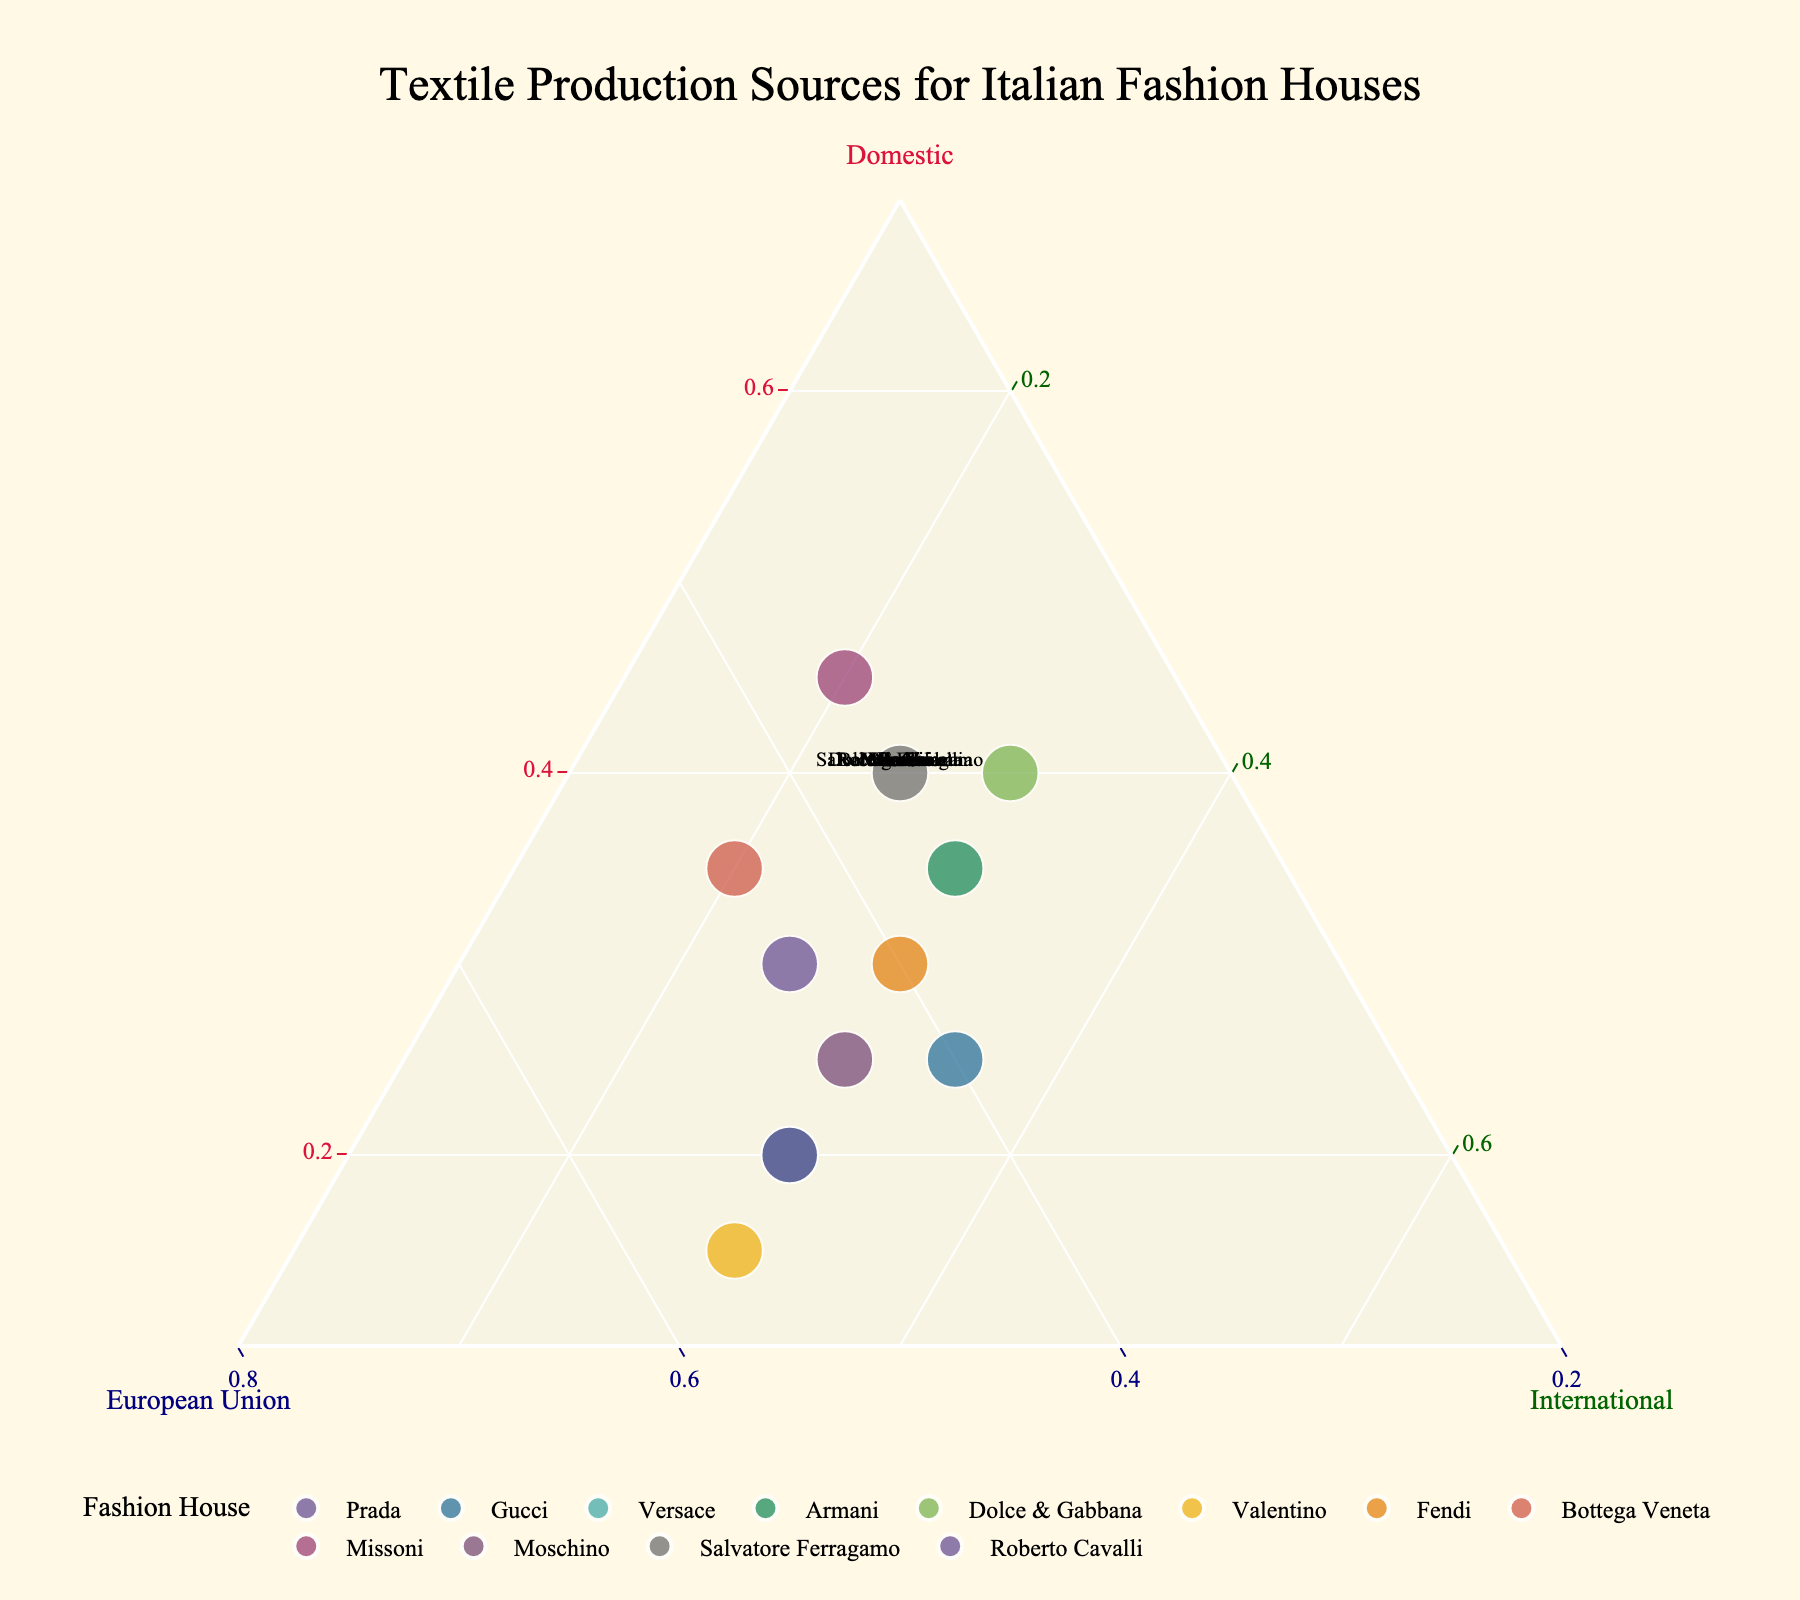what is the title of the plot? The title of the plot is located at the top center of the figure. Based on the code provided, the title is "Textile Production Sources for Italian Fashion Houses".
Answer: Textiles Production Sources for Italian Fashion Houses Which fashion house has the highest proportion of domestic textile production? The points representing each fashion house can be located within the ternary plot. By observing the axis labeled "Domestic" and finding the point closest to the vertex of that axis, Missoni has the highest proportion of domestic textile production, being closer to the Domestic vertex.
Answer: Missoni What is the balance of textile production for Versace between Domestic, European Union, and International sources? To determine the balance for Versace, we look for the point labeled "Versace". The proportions for Domestic, EU, and International can be read from the ternary coordinates: 20% Domestic, 50% European Union, and 30% International as shown in the data.
Answer: 20% Domestic, 50% European Union, 30% International Which fashion house has the largest proportion of textile production sourced from the European Union? Reviewing the labels and their positions in the ternary plot, Valentino is closest to the vertex labeled "European Union", indicating this fashion house sources the largest proportion from EU.
Answer: Valentino Comparing Prada and Gucci, which one relies more on international textile sources? Observing the plot, the "International" component for each house can be estimated. Gucci's proportion is closer to the International vertex compared to Prada, indicating it relies more on international textile sources.
Answer: Gucci Which fashion houses have an equal proportion of their textile production sourced from domestic and international regions? By examining the figure and locating points on the line where Domestic and International axes are equal, Dolce & Gabbana and Fendi both show these equal proportions as they lie on lines where the percentages of these sources are equal.
Answer: Dolce & Gabbana, Fendi For Armani, if the proportion of EU sources is increased by 10% while reducing Domestic by the same amount, what will the new coordinates be? original proportions: 35% Domestic, 35% EU, 30% International. After changes: Adjusted Domestic = 25%, Adjusted EU = 45%, International remains = 30%. Normalizing: Domestic = 25/100, EU = 45/100, International = 30/100. New coordinates will reflect the increased EU proportion with decreased Domestic.
Answer: 25% Domestic, 45% EU, 30% International Which fashion house is closest to having an equal split between all three textile production sources? By analyzing points that are near the center of the ternary plot (equal distances from each vertex), Armani is closest to having an equal split, as the proportions are almost balanced at 35% Domestic, 35% EU, 30% International.
Answer: Armani If we consider only those fashion houses that have at least 30% of textile production sourced domestically, which ones fit this criterion? Observing points where the Domestic value is 30% or more: Prada, Armani, Dolce & Gabbana, Fendi, Bottega Veneta, Missoni, Salvatore Ferragamo are identified around or surpassing the 30% mark.
Answer: Prada, Armani, Dolce & Gabbana, Fendi, Bottega Veneta, Missoni, Salvatore Ferragamo 